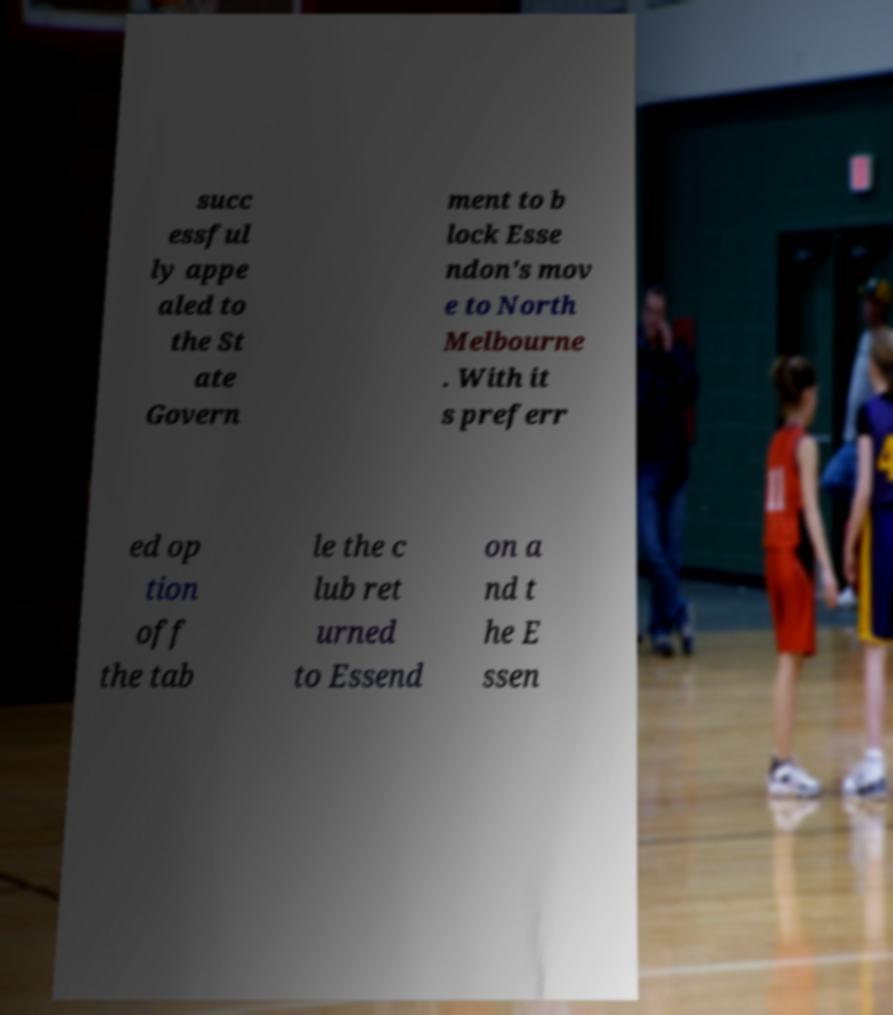There's text embedded in this image that I need extracted. Can you transcribe it verbatim? succ essful ly appe aled to the St ate Govern ment to b lock Esse ndon's mov e to North Melbourne . With it s preferr ed op tion off the tab le the c lub ret urned to Essend on a nd t he E ssen 